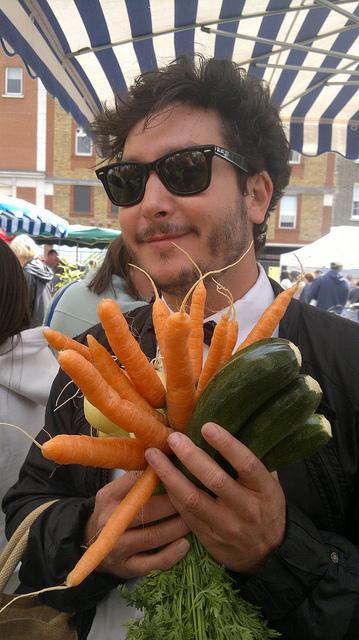What kind of green vegetable is held underneath of the carrots like a card? Please explain your reasoning. cucumber. Those types of veggies are like pickles and long. 